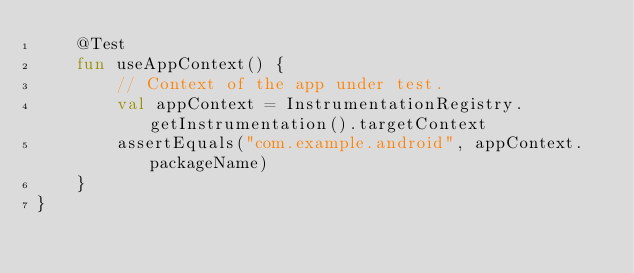<code> <loc_0><loc_0><loc_500><loc_500><_Kotlin_>    @Test
    fun useAppContext() {
        // Context of the app under test.
        val appContext = InstrumentationRegistry.getInstrumentation().targetContext
        assertEquals("com.example.android", appContext.packageName)
    }
}</code> 